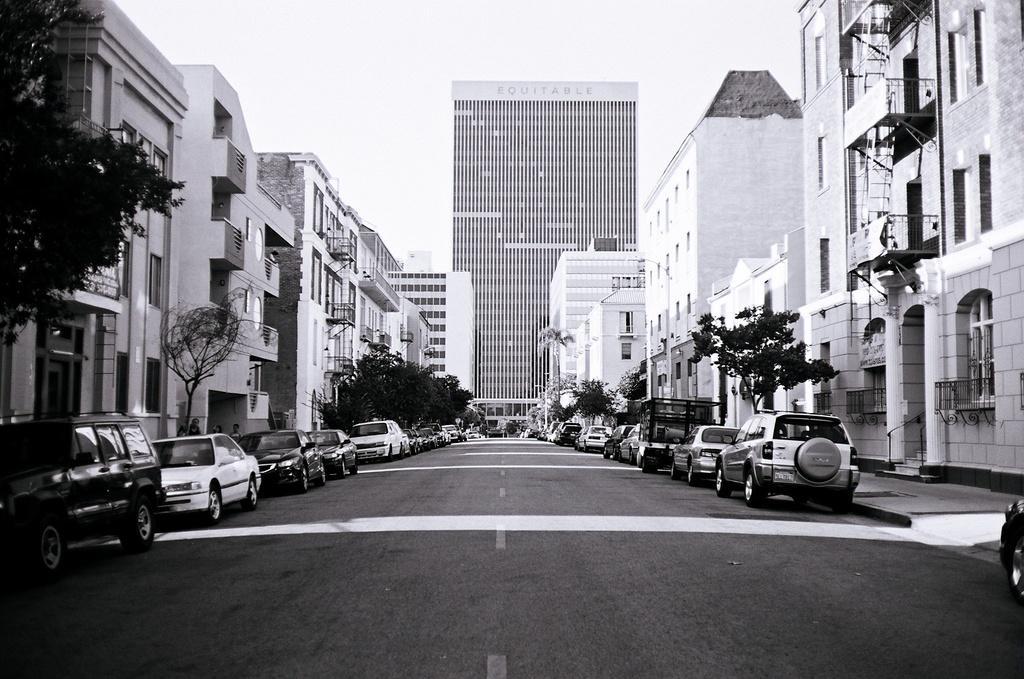How would you summarize this image in a sentence or two? This is a black and white image. In the center of the image there is road with cars. To both sides of the image there are buildings. In the background of the image there is building and sky. 